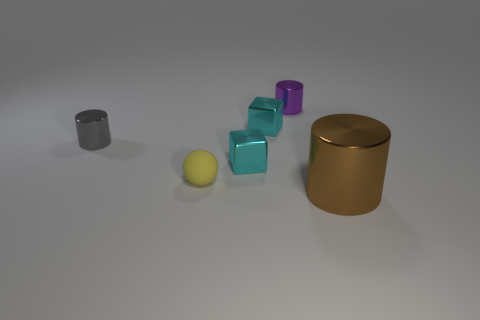What colors are the small cubes displayed in the image? The image showcases small cubes in various colors, specifically purple, teal, and two in metallic brown. 